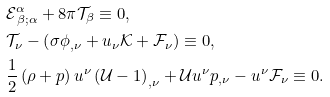<formula> <loc_0><loc_0><loc_500><loc_500>& \mathcal { E } ^ { \alpha } _ { \, \beta ; \alpha } + 8 \pi \mathcal { T } _ { \beta } \equiv 0 , \\ & \mathcal { T } _ { \nu } - \left ( \sigma \phi _ { , \nu } + u _ { \nu } \mathcal { K } + \mathcal { F } _ { \nu } \right ) \equiv 0 , \\ & \frac { 1 } { 2 } \left ( \rho + p \right ) u ^ { \nu } \left ( \mathcal { U } - 1 \right ) _ { , \nu } + \mathcal { U } u ^ { \nu } p _ { , \nu } - u ^ { \nu } \mathcal { F } _ { \nu } \equiv 0 .</formula> 